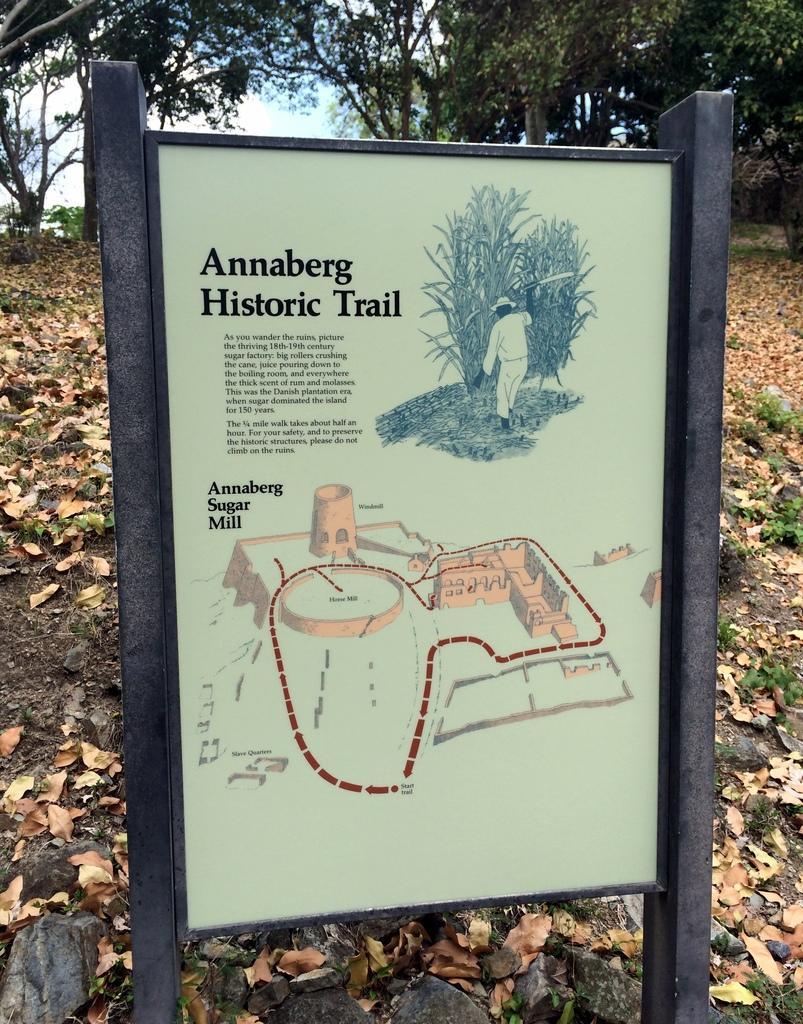Can you describe this image briefly? In this image, we can see a board with poles. At the bottom, we can see few stones. Top of the image, there are so many trees we can see. On the board, we can see some images and text. 